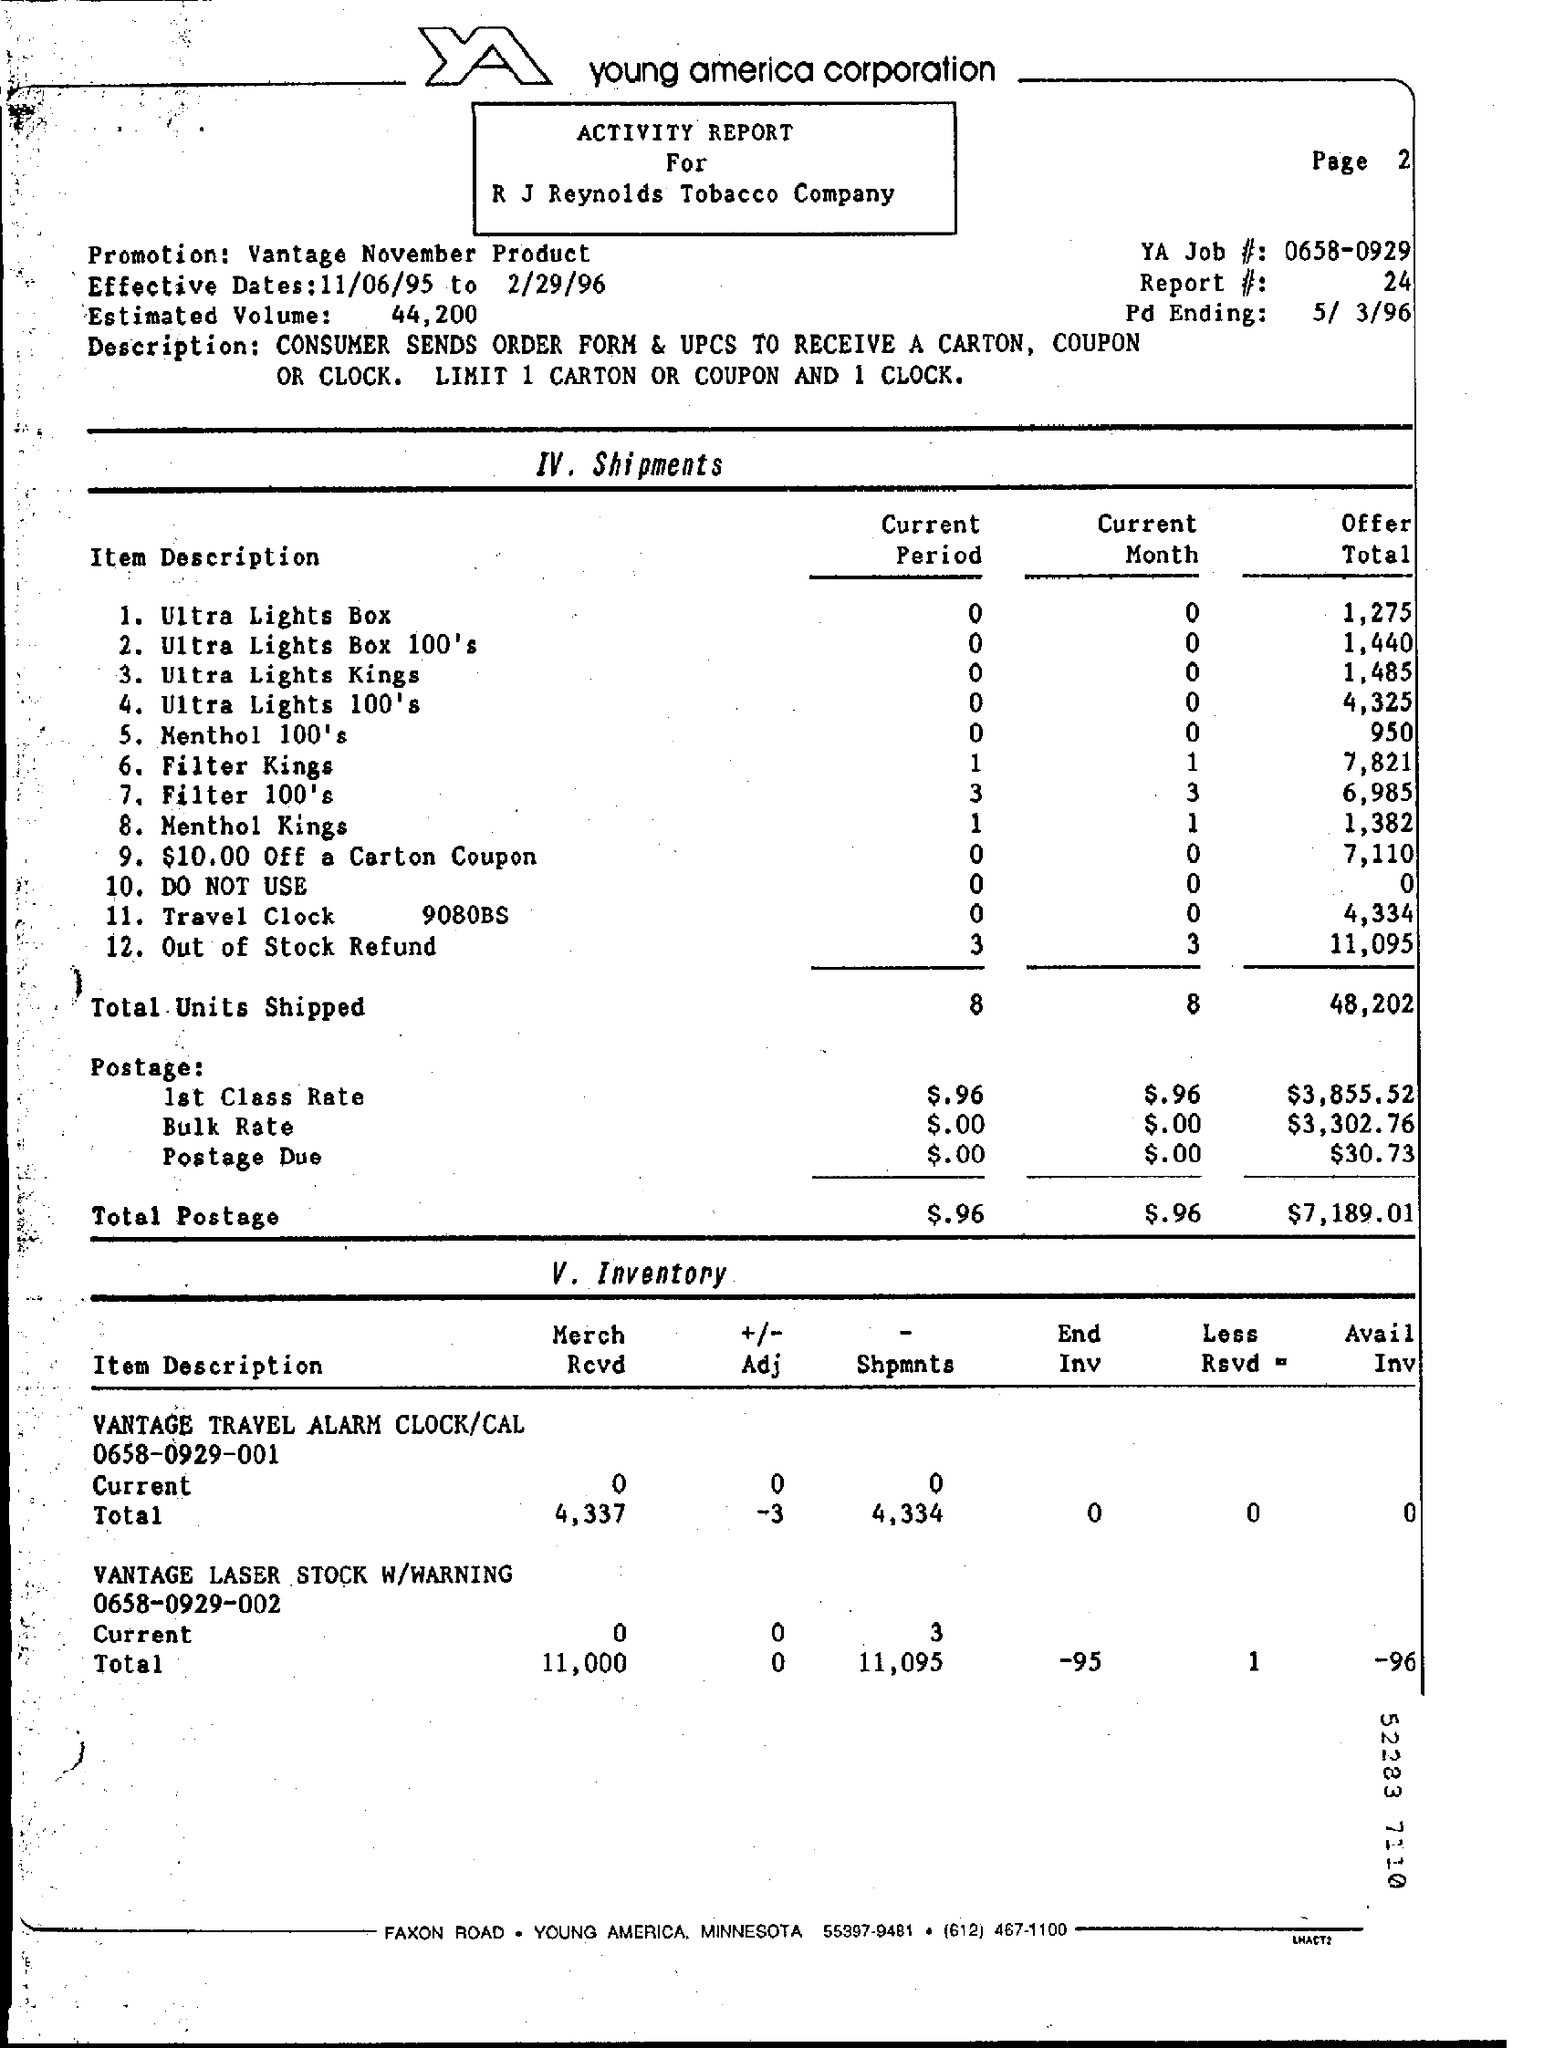What is the estimated volume given in the activity report ?
Offer a terse response. 44,200. What are the effective dates mentioned in the activity report ?
Ensure brevity in your answer.  11/06/95 to 2/29/96. How many total units are shipped in the current period ?
Keep it short and to the point. 8. How many total units are shipped in the current month ?
Your response must be concise. 8. What is the value of offer total for filter kings ?
Make the answer very short. 7,821. What is the amount of total postage for the current period ?
Give a very brief answer. $.96. How many shipments of menthol kings have been done during the current period ?
Your answer should be compact. 1. What is the offer total value for ultra lights box ?
Your answer should be compact. 1,275. What is the amount of offer total for total units shipped as mentioned in the activity report ?
Your answer should be compact. 48,202. 